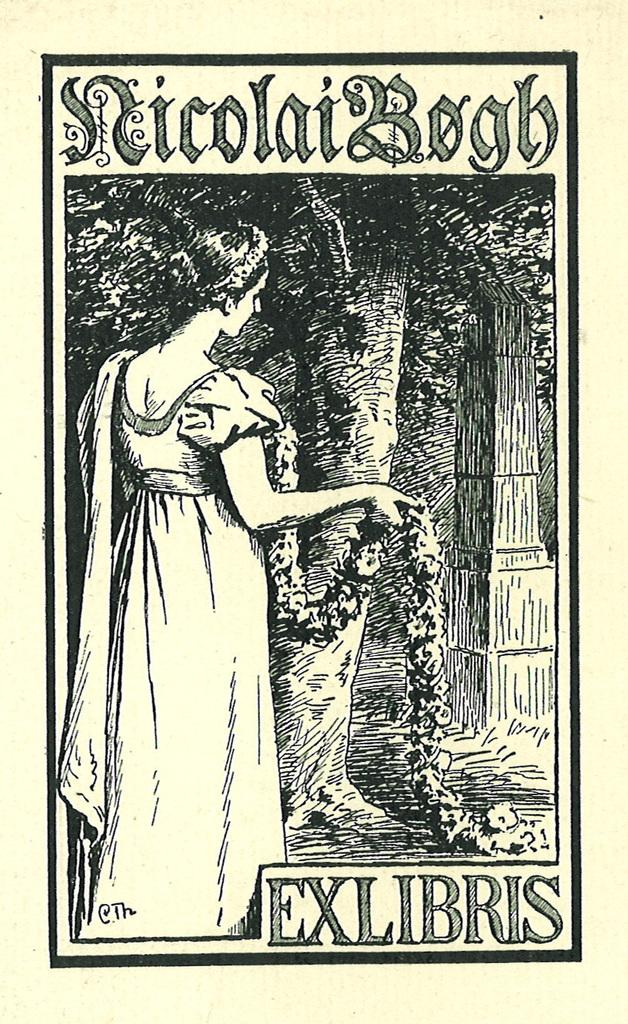Who is present in the image? There is a woman in the image. What is the woman wearing in the image? The woman is wearing a garland in the image. What can be seen in the background of the image? There is a tree in the image. Are there any words or letters in the image? Yes, the image contains text. What type of boat can be seen docked at the harbor in the image? There is no harbor or boat present in the image; it features a woman wearing a garland and a tree in the background. 